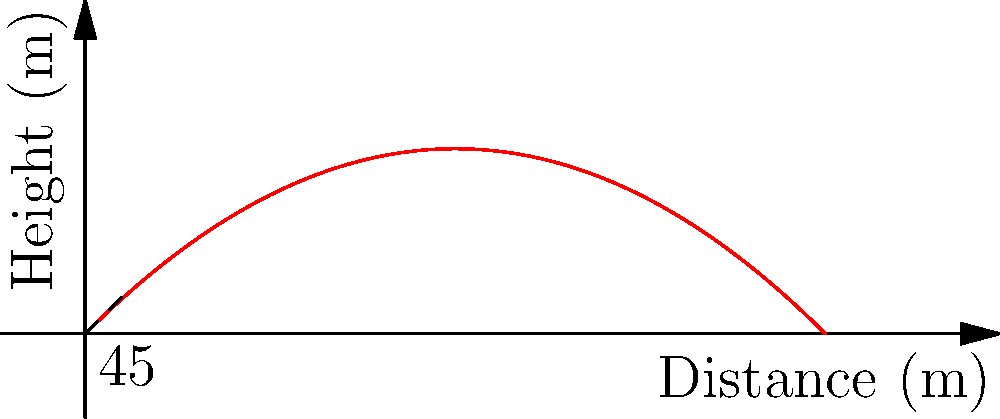A missile is launched with an initial velocity of 100 m/s at a 45-degree angle from the horizontal. Assuming no air resistance, what is the maximum height reached by the missile? To find the maximum height of the missile, we can follow these steps:

1) The vertical component of the initial velocity is:
   $v_{0y} = v_0 \sin(\theta) = 100 \cdot \sin(45°) = 70.71$ m/s

2) The time to reach the maximum height is when the vertical velocity becomes zero:
   $t_{max} = \frac{v_{0y}}{g} = \frac{70.71}{9.8} = 7.21$ seconds

3) The maximum height can be calculated using the equation:
   $h_{max} = v_{0y}t - \frac{1}{2}gt^2$

4) Substituting the values:
   $h_{max} = 70.71 \cdot 7.21 - \frac{1}{2} \cdot 9.8 \cdot 7.21^2$
   
5) Calculating:
   $h_{max} = 509.82 - 254.91 = 254.91$ meters

Therefore, the maximum height reached by the missile is approximately 254.91 meters.
Answer: 254.91 meters 